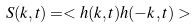<formula> <loc_0><loc_0><loc_500><loc_500>S ( { k } , t ) = < h ( { k } , t ) h ( - { k } , t ) > \\</formula> 